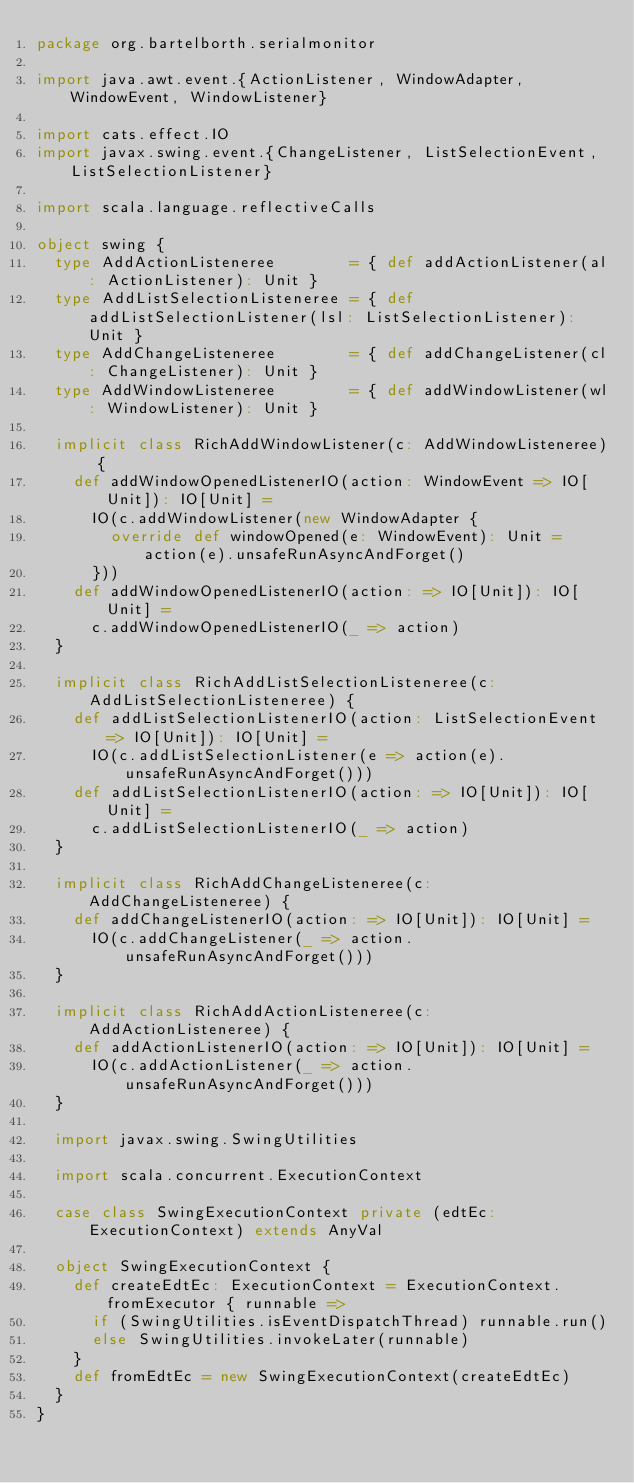<code> <loc_0><loc_0><loc_500><loc_500><_Scala_>package org.bartelborth.serialmonitor

import java.awt.event.{ActionListener, WindowAdapter, WindowEvent, WindowListener}

import cats.effect.IO
import javax.swing.event.{ChangeListener, ListSelectionEvent, ListSelectionListener}

import scala.language.reflectiveCalls

object swing {
  type AddActionListeneree        = { def addActionListener(al: ActionListener): Unit }
  type AddListSelectionListeneree = { def addListSelectionListener(lsl: ListSelectionListener): Unit }
  type AddChangeListeneree        = { def addChangeListener(cl: ChangeListener): Unit }
  type AddWindowListeneree        = { def addWindowListener(wl: WindowListener): Unit }

  implicit class RichAddWindowListener(c: AddWindowListeneree) {
    def addWindowOpenedListenerIO(action: WindowEvent => IO[Unit]): IO[Unit] =
      IO(c.addWindowListener(new WindowAdapter {
        override def windowOpened(e: WindowEvent): Unit = action(e).unsafeRunAsyncAndForget()
      }))
    def addWindowOpenedListenerIO(action: => IO[Unit]): IO[Unit] =
      c.addWindowOpenedListenerIO(_ => action)
  }

  implicit class RichAddListSelectionListeneree(c: AddListSelectionListeneree) {
    def addListSelectionListenerIO(action: ListSelectionEvent => IO[Unit]): IO[Unit] =
      IO(c.addListSelectionListener(e => action(e).unsafeRunAsyncAndForget()))
    def addListSelectionListenerIO(action: => IO[Unit]): IO[Unit] =
      c.addListSelectionListenerIO(_ => action)
  }

  implicit class RichAddChangeListeneree(c: AddChangeListeneree) {
    def addChangeListenerIO(action: => IO[Unit]): IO[Unit] =
      IO(c.addChangeListener(_ => action.unsafeRunAsyncAndForget()))
  }

  implicit class RichAddActionListeneree(c: AddActionListeneree) {
    def addActionListenerIO(action: => IO[Unit]): IO[Unit] =
      IO(c.addActionListener(_ => action.unsafeRunAsyncAndForget()))
  }

  import javax.swing.SwingUtilities

  import scala.concurrent.ExecutionContext

  case class SwingExecutionContext private (edtEc: ExecutionContext) extends AnyVal

  object SwingExecutionContext {
    def createEdtEc: ExecutionContext = ExecutionContext.fromExecutor { runnable =>
      if (SwingUtilities.isEventDispatchThread) runnable.run()
      else SwingUtilities.invokeLater(runnable)
    }
    def fromEdtEc = new SwingExecutionContext(createEdtEc)
  }
}
</code> 